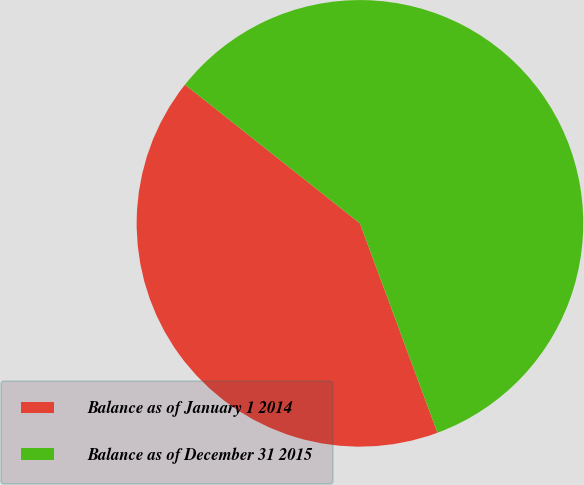Convert chart to OTSL. <chart><loc_0><loc_0><loc_500><loc_500><pie_chart><fcel>Balance as of January 1 2014<fcel>Balance as of December 31 2015<nl><fcel>41.31%<fcel>58.69%<nl></chart> 